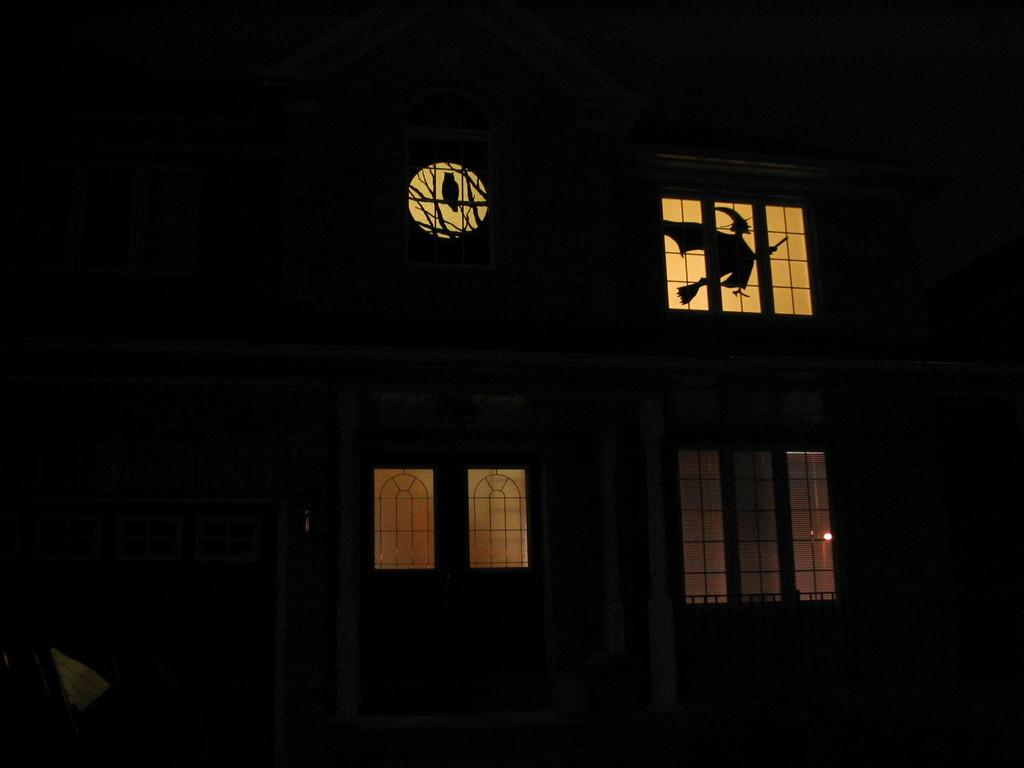What is the overall lighting condition of the image? The image is dark. What type of structure can be seen in the image? There is a building in the image. Are there any openings in the building visible in the image? Yes, there are windows in the image. What type of fish can be seen swimming through the pipes in the image? There are no fish or pipes present in the image; it features a dark image of a building with windows. 